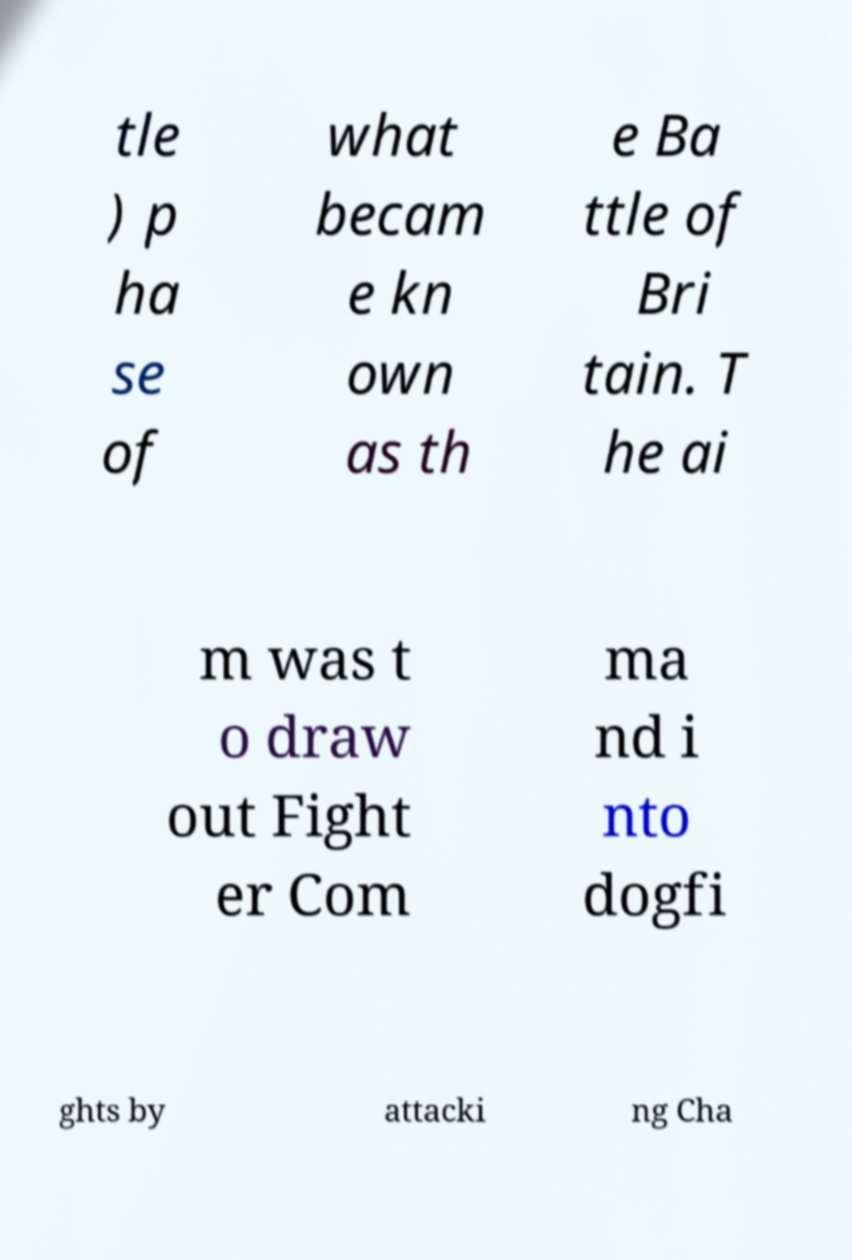I need the written content from this picture converted into text. Can you do that? tle ) p ha se of what becam e kn own as th e Ba ttle of Bri tain. T he ai m was t o draw out Fight er Com ma nd i nto dogfi ghts by attacki ng Cha 